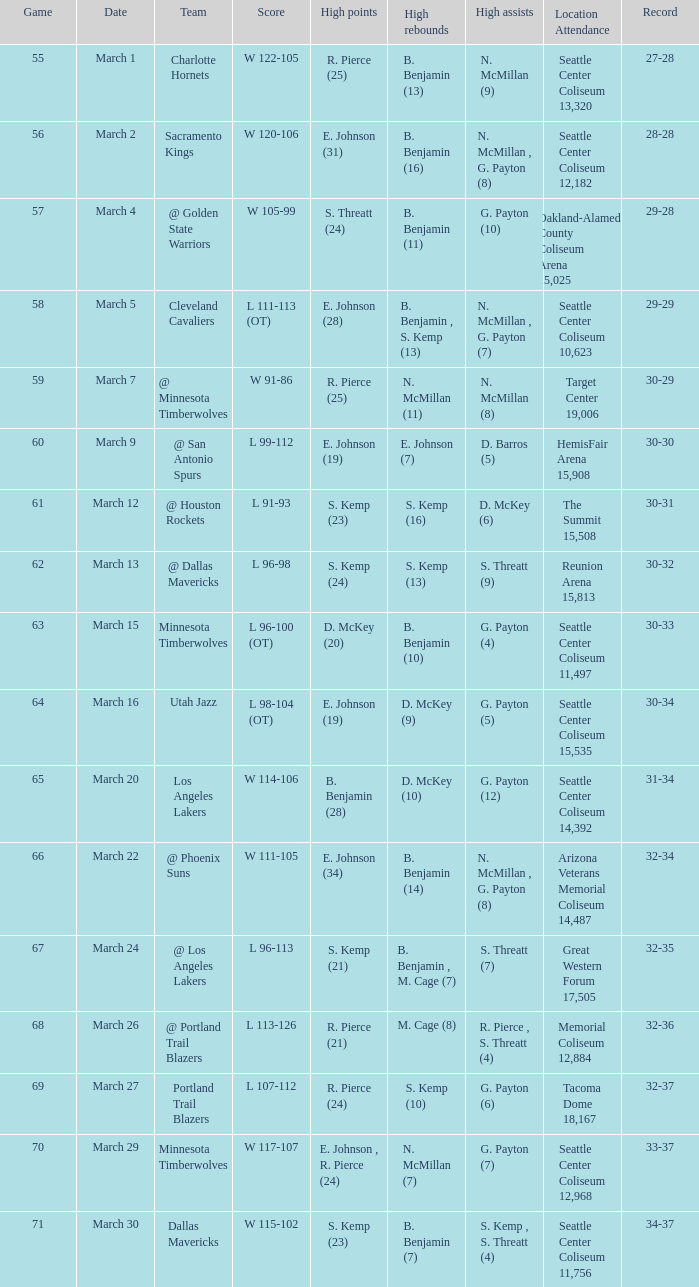In which game did s. threatt achieve 9 high assists? 62.0. 